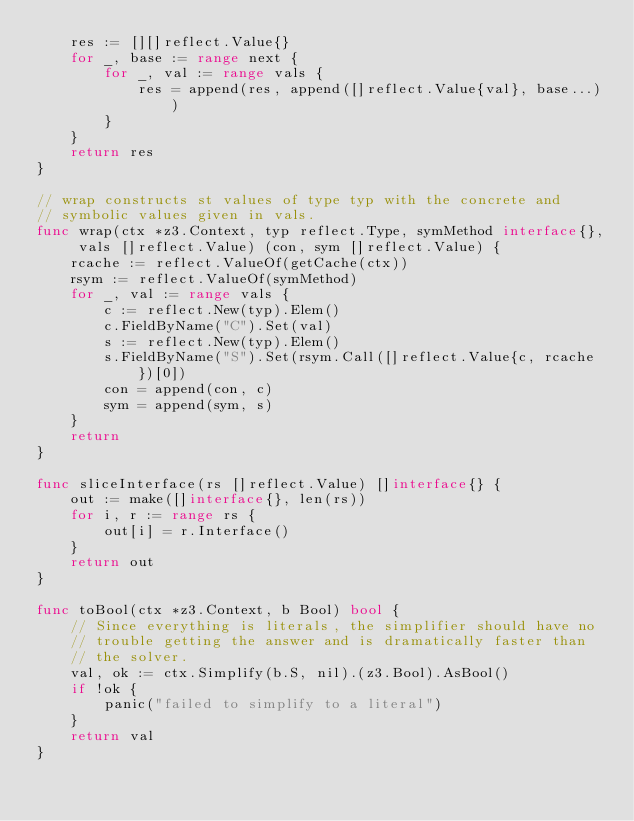<code> <loc_0><loc_0><loc_500><loc_500><_Go_>	res := [][]reflect.Value{}
	for _, base := range next {
		for _, val := range vals {
			res = append(res, append([]reflect.Value{val}, base...))
		}
	}
	return res
}

// wrap constructs st values of type typ with the concrete and
// symbolic values given in vals.
func wrap(ctx *z3.Context, typ reflect.Type, symMethod interface{}, vals []reflect.Value) (con, sym []reflect.Value) {
	rcache := reflect.ValueOf(getCache(ctx))
	rsym := reflect.ValueOf(symMethod)
	for _, val := range vals {
		c := reflect.New(typ).Elem()
		c.FieldByName("C").Set(val)
		s := reflect.New(typ).Elem()
		s.FieldByName("S").Set(rsym.Call([]reflect.Value{c, rcache})[0])
		con = append(con, c)
		sym = append(sym, s)
	}
	return
}

func sliceInterface(rs []reflect.Value) []interface{} {
	out := make([]interface{}, len(rs))
	for i, r := range rs {
		out[i] = r.Interface()
	}
	return out
}

func toBool(ctx *z3.Context, b Bool) bool {
	// Since everything is literals, the simplifier should have no
	// trouble getting the answer and is dramatically faster than
	// the solver.
	val, ok := ctx.Simplify(b.S, nil).(z3.Bool).AsBool()
	if !ok {
		panic("failed to simplify to a literal")
	}
	return val
}
</code> 